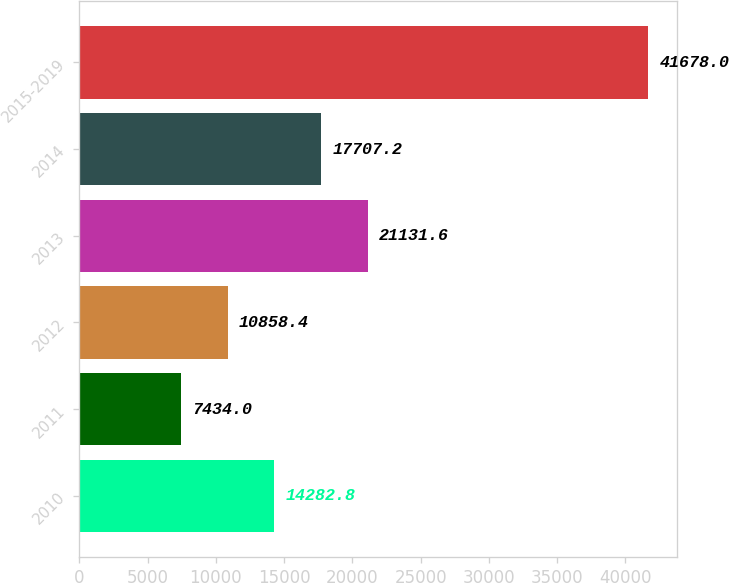Convert chart. <chart><loc_0><loc_0><loc_500><loc_500><bar_chart><fcel>2010<fcel>2011<fcel>2012<fcel>2013<fcel>2014<fcel>2015-2019<nl><fcel>14282.8<fcel>7434<fcel>10858.4<fcel>21131.6<fcel>17707.2<fcel>41678<nl></chart> 